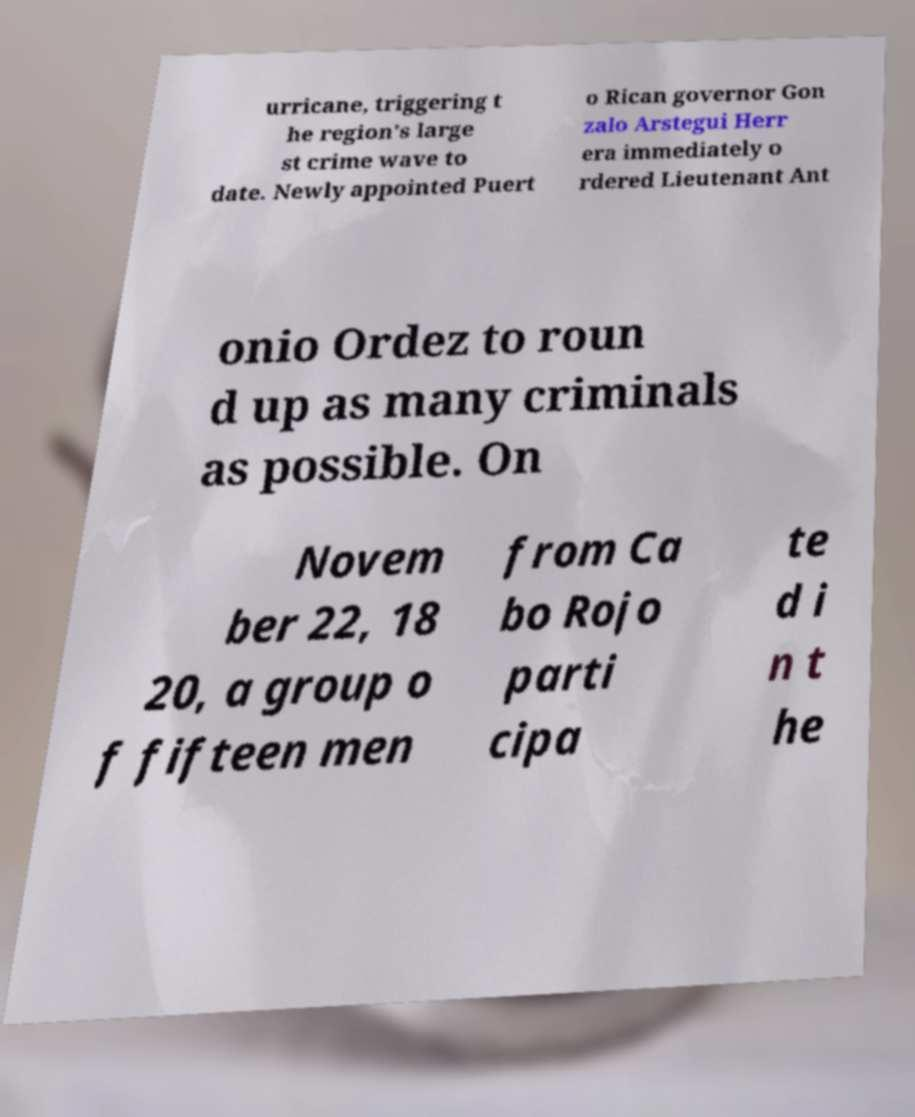Could you extract and type out the text from this image? urricane, triggering t he region's large st crime wave to date. Newly appointed Puert o Rican governor Gon zalo Arstegui Herr era immediately o rdered Lieutenant Ant onio Ordez to roun d up as many criminals as possible. On Novem ber 22, 18 20, a group o f fifteen men from Ca bo Rojo parti cipa te d i n t he 